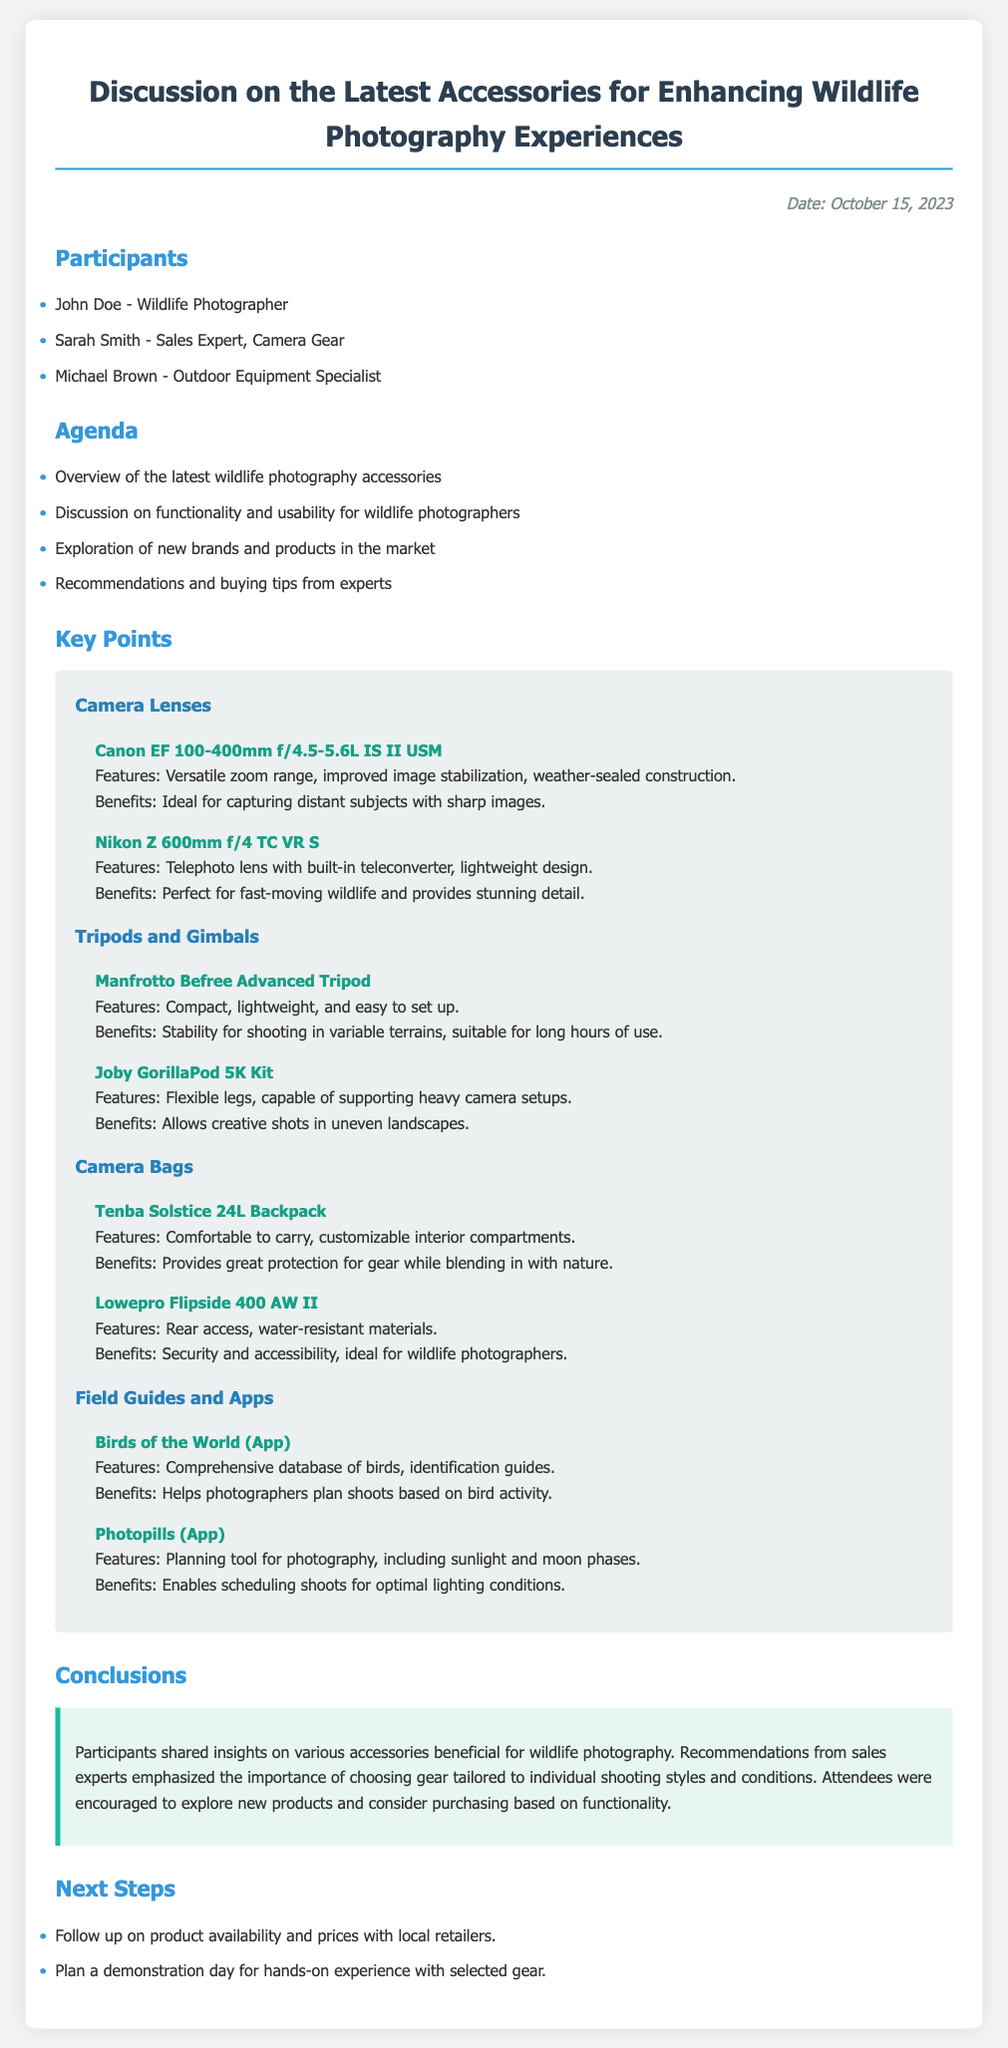What was the date of the meeting? The date of the meeting is provided in the document, specified as October 15, 2023.
Answer: October 15, 2023 Who is the Sales Expert listed among the participants? The document lists Sarah Smith as the Sales Expert among the participants.
Answer: Sarah Smith What is one feature of the Canon EF 100-400mm f/4.5-5.6L IS II USM lens? The document mentions that the Canon lens has improved image stabilization as one of its features.
Answer: Improved image stabilization What type of product is the Joby GorillaPod 5K Kit? The document classifies the Joby GorillaPod 5K Kit as a tripod and gimbal used for stabilizing photography gear.
Answer: Tripod and gimbal Which app helps photographers plan shoots based on bird activity? The document indicates that "Birds of the World" is an app that assists in planning shoots based on bird activity.
Answer: Birds of the World What was emphasized regarding choosing gear? The document emphasizes the importance of selecting gear tailored to individual shooting styles and conditions.
Answer: Tailored to individual shooting styles What is one benefit of the Lowepro Flipside 400 AW II camera bag? The document states that the Lowepro bag offers security and accessibility for wildlife photographers.
Answer: Security and accessibility What is the next step planned according to the minutes? The document notes following up on product availability and prices with local retailers as a next step.
Answer: Follow up on product availability and prices 